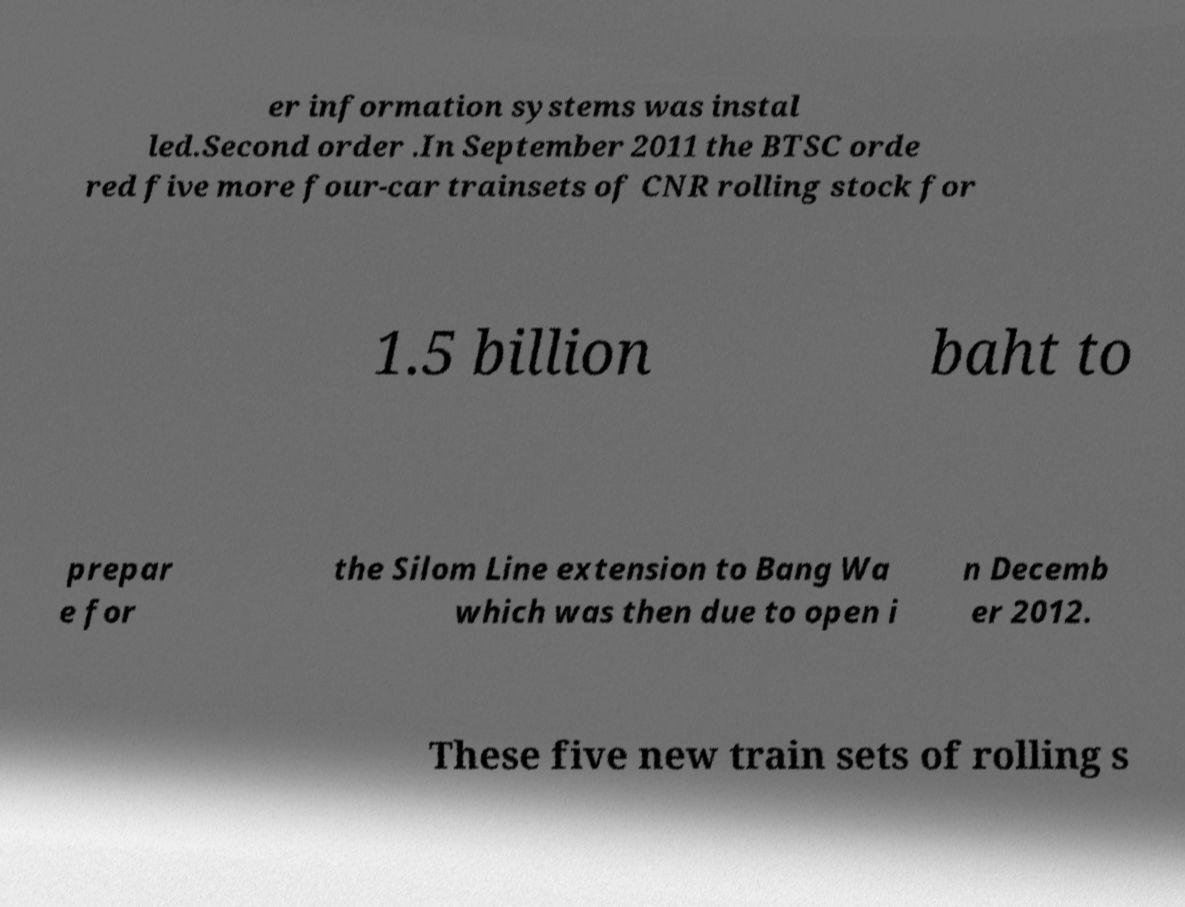Can you read and provide the text displayed in the image?This photo seems to have some interesting text. Can you extract and type it out for me? er information systems was instal led.Second order .In September 2011 the BTSC orde red five more four-car trainsets of CNR rolling stock for 1.5 billion baht to prepar e for the Silom Line extension to Bang Wa which was then due to open i n Decemb er 2012. These five new train sets of rolling s 